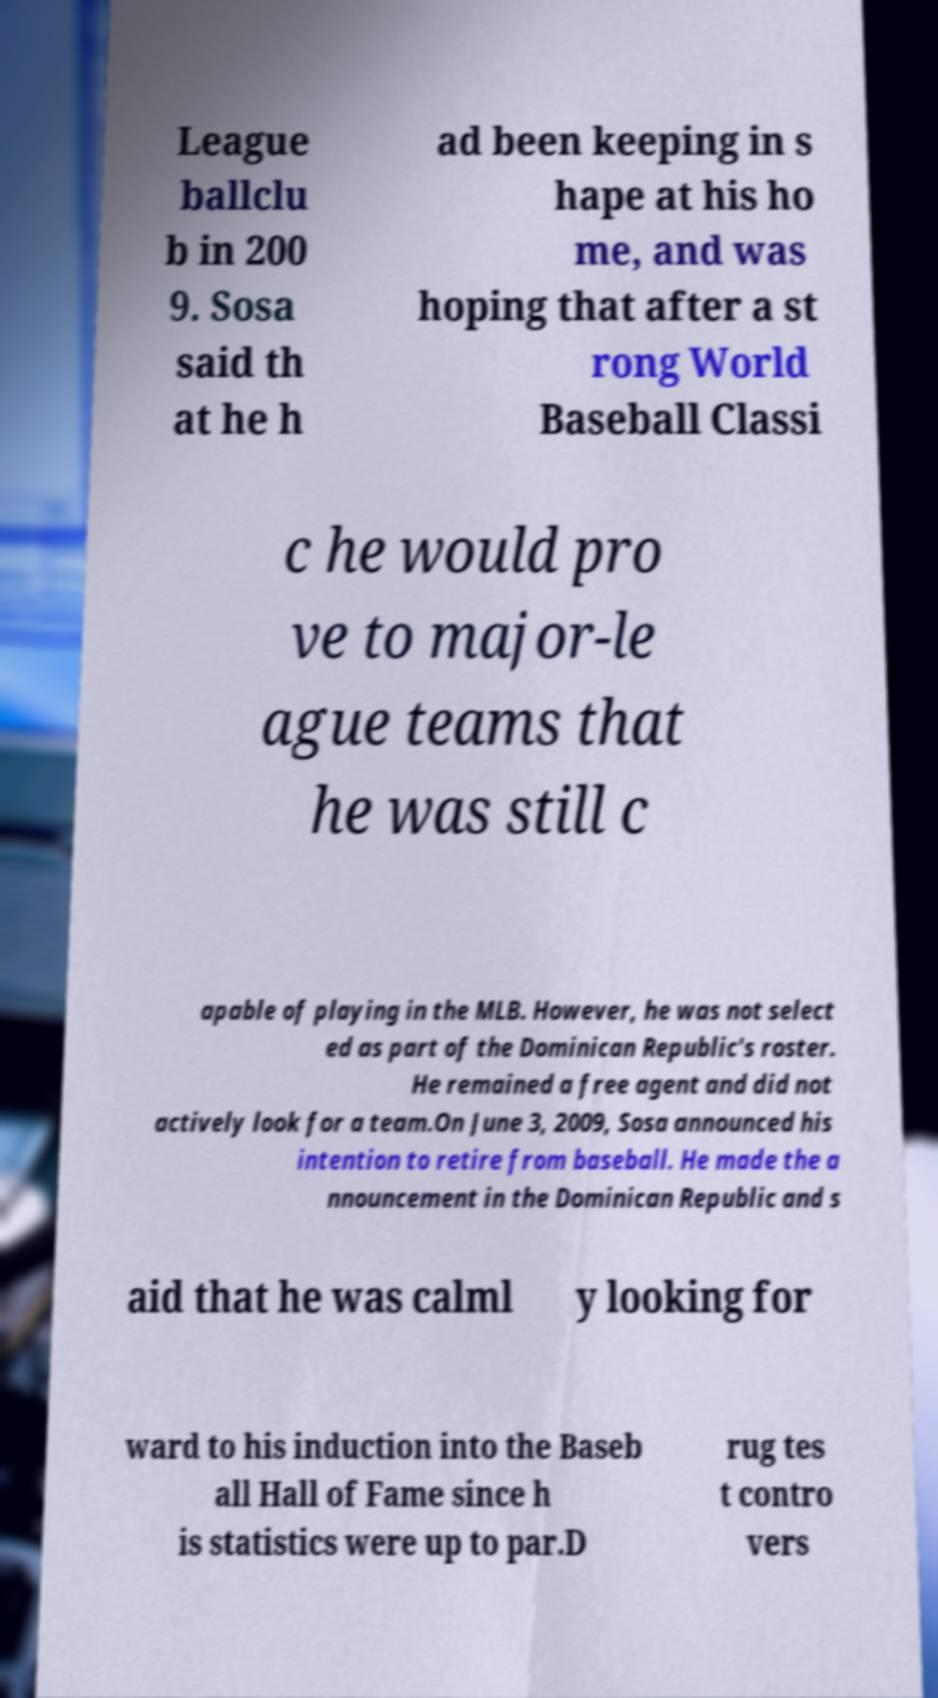Can you accurately transcribe the text from the provided image for me? League ballclu b in 200 9. Sosa said th at he h ad been keeping in s hape at his ho me, and was hoping that after a st rong World Baseball Classi c he would pro ve to major-le ague teams that he was still c apable of playing in the MLB. However, he was not select ed as part of the Dominican Republic's roster. He remained a free agent and did not actively look for a team.On June 3, 2009, Sosa announced his intention to retire from baseball. He made the a nnouncement in the Dominican Republic and s aid that he was calml y looking for ward to his induction into the Baseb all Hall of Fame since h is statistics were up to par.D rug tes t contro vers 